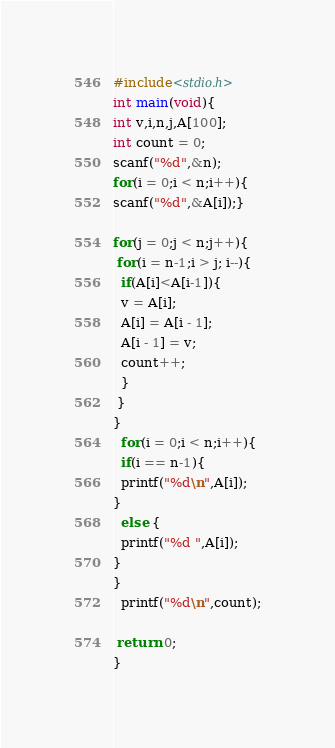<code> <loc_0><loc_0><loc_500><loc_500><_C_>#include<stdio.h>
int main(void){
int v,i,n,j,A[100];
int count = 0;
scanf("%d",&n);
for(i = 0;i < n;i++){
scanf("%d",&A[i]);}

for(j = 0;j < n;j++){
 for(i = n-1;i > j; i--){
  if(A[i]<A[i-1]){
  v = A[i];
  A[i] = A[i - 1];
  A[i - 1] = v;
  count++;
  }
 }
}
  for(i = 0;i < n;i++){
  if(i == n-1){
  printf("%d\n",A[i]);
}
  else {
  printf("%d ",A[i]);
}
}
  printf("%d\n",count);

 return 0;
}</code> 